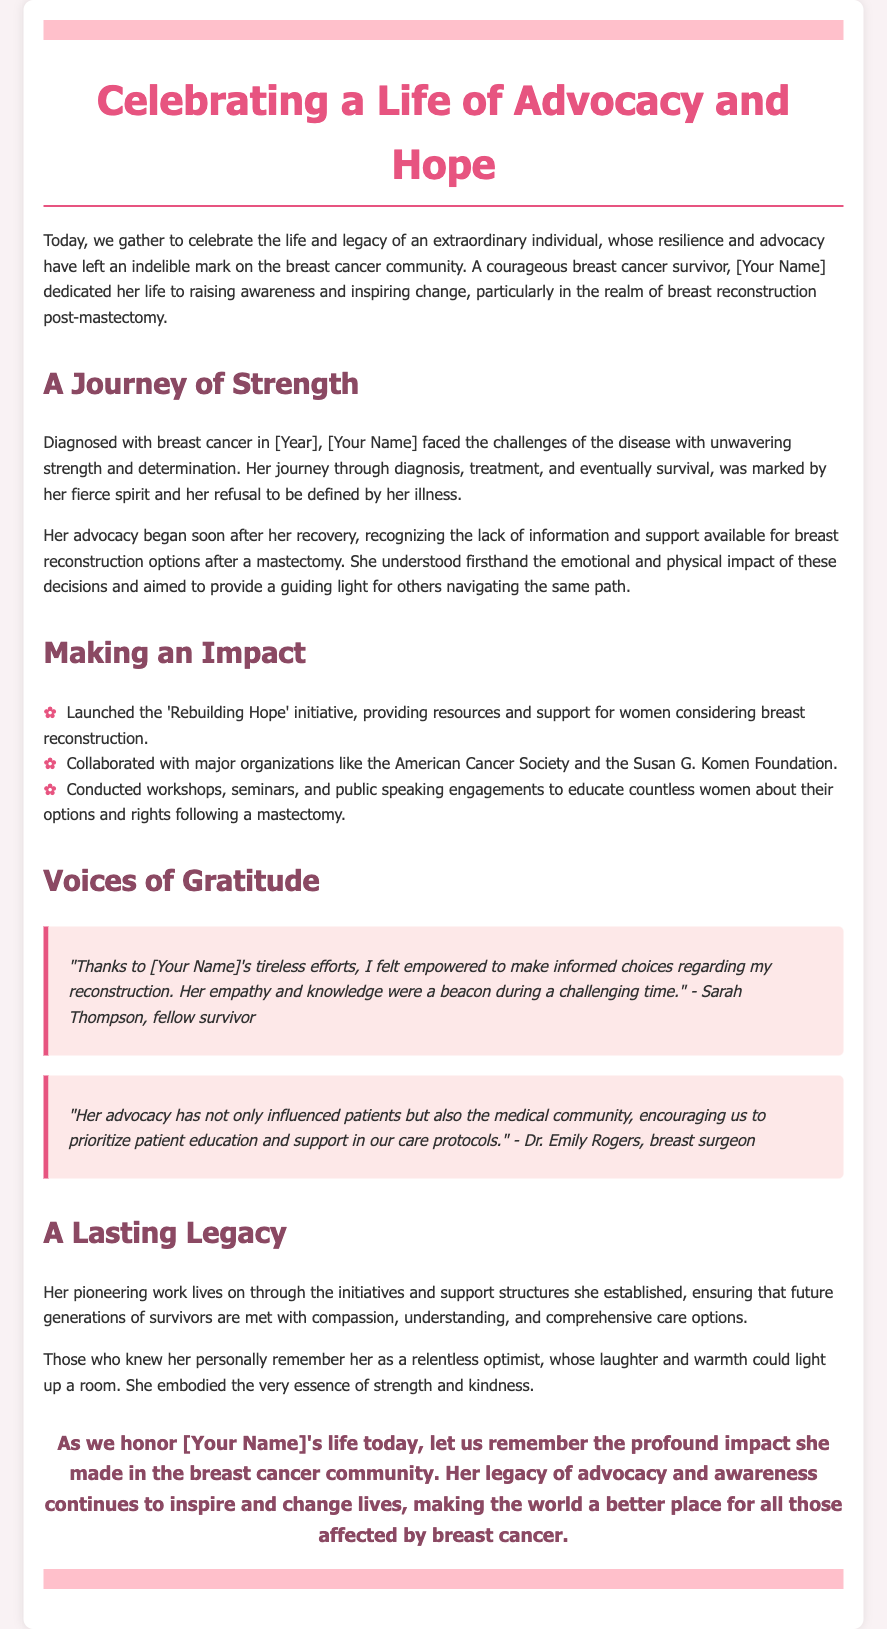What was the name of the initiative launched by [Your Name]? The initiative launched was aimed at providing resources for breast reconstruction after a mastectomy.
Answer: Rebuilding Hope In which year was [Your Name] diagnosed with breast cancer? The document specifically mentions the year of diagnosis.
Answer: [Year] Who collaborated with [Your Name] on her advocacy efforts? The document mentions major organizations involved with her advocacy.
Answer: American Cancer Society and Susan G. Komen Foundation What did the workshops and seminars conducted by [Your Name] focus on? The workshops and seminars were aimed at educating women about specific topics.
Answer: Breast reconstruction options Who expressed gratitude for [Your Name]'s efforts in the document? The quote reflects appreciation from individuals impacted by her advocacy.
Answer: Sarah Thompson What was notable about [Your Name] according to the document? This quality is mentioned to highlight her personality and influence on others.
Answer: Relentless optimist What is mentioned as [Your Name]'s lasting legacy? The document highlights the continuation of her work and its impact on future survivors.
Answer: Comprehensive care options What was emphasized by Dr. Emily Rogers regarding [Your Name]'s advocacy? The document reflects a significant change in perspective as a result of her work.
Answer: Patient education and support 